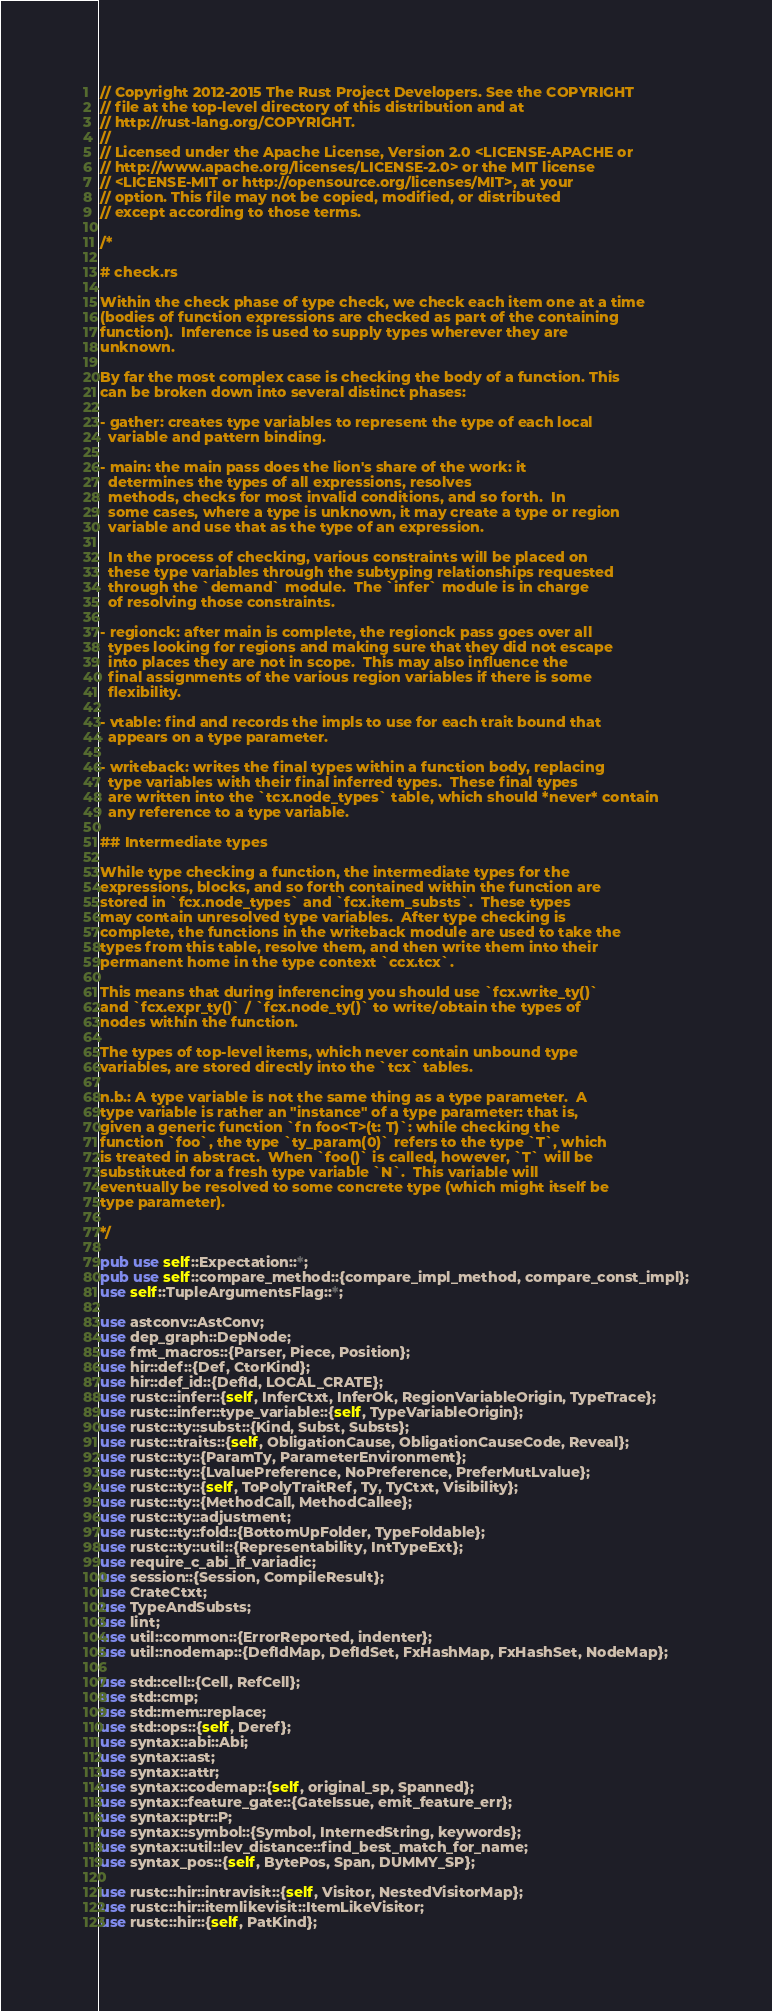Convert code to text. <code><loc_0><loc_0><loc_500><loc_500><_Rust_>// Copyright 2012-2015 The Rust Project Developers. See the COPYRIGHT
// file at the top-level directory of this distribution and at
// http://rust-lang.org/COPYRIGHT.
//
// Licensed under the Apache License, Version 2.0 <LICENSE-APACHE or
// http://www.apache.org/licenses/LICENSE-2.0> or the MIT license
// <LICENSE-MIT or http://opensource.org/licenses/MIT>, at your
// option. This file may not be copied, modified, or distributed
// except according to those terms.

/*

# check.rs

Within the check phase of type check, we check each item one at a time
(bodies of function expressions are checked as part of the containing
function).  Inference is used to supply types wherever they are
unknown.

By far the most complex case is checking the body of a function. This
can be broken down into several distinct phases:

- gather: creates type variables to represent the type of each local
  variable and pattern binding.

- main: the main pass does the lion's share of the work: it
  determines the types of all expressions, resolves
  methods, checks for most invalid conditions, and so forth.  In
  some cases, where a type is unknown, it may create a type or region
  variable and use that as the type of an expression.

  In the process of checking, various constraints will be placed on
  these type variables through the subtyping relationships requested
  through the `demand` module.  The `infer` module is in charge
  of resolving those constraints.

- regionck: after main is complete, the regionck pass goes over all
  types looking for regions and making sure that they did not escape
  into places they are not in scope.  This may also influence the
  final assignments of the various region variables if there is some
  flexibility.

- vtable: find and records the impls to use for each trait bound that
  appears on a type parameter.

- writeback: writes the final types within a function body, replacing
  type variables with their final inferred types.  These final types
  are written into the `tcx.node_types` table, which should *never* contain
  any reference to a type variable.

## Intermediate types

While type checking a function, the intermediate types for the
expressions, blocks, and so forth contained within the function are
stored in `fcx.node_types` and `fcx.item_substs`.  These types
may contain unresolved type variables.  After type checking is
complete, the functions in the writeback module are used to take the
types from this table, resolve them, and then write them into their
permanent home in the type context `ccx.tcx`.

This means that during inferencing you should use `fcx.write_ty()`
and `fcx.expr_ty()` / `fcx.node_ty()` to write/obtain the types of
nodes within the function.

The types of top-level items, which never contain unbound type
variables, are stored directly into the `tcx` tables.

n.b.: A type variable is not the same thing as a type parameter.  A
type variable is rather an "instance" of a type parameter: that is,
given a generic function `fn foo<T>(t: T)`: while checking the
function `foo`, the type `ty_param(0)` refers to the type `T`, which
is treated in abstract.  When `foo()` is called, however, `T` will be
substituted for a fresh type variable `N`.  This variable will
eventually be resolved to some concrete type (which might itself be
type parameter).

*/

pub use self::Expectation::*;
pub use self::compare_method::{compare_impl_method, compare_const_impl};
use self::TupleArgumentsFlag::*;

use astconv::AstConv;
use dep_graph::DepNode;
use fmt_macros::{Parser, Piece, Position};
use hir::def::{Def, CtorKind};
use hir::def_id::{DefId, LOCAL_CRATE};
use rustc::infer::{self, InferCtxt, InferOk, RegionVariableOrigin, TypeTrace};
use rustc::infer::type_variable::{self, TypeVariableOrigin};
use rustc::ty::subst::{Kind, Subst, Substs};
use rustc::traits::{self, ObligationCause, ObligationCauseCode, Reveal};
use rustc::ty::{ParamTy, ParameterEnvironment};
use rustc::ty::{LvaluePreference, NoPreference, PreferMutLvalue};
use rustc::ty::{self, ToPolyTraitRef, Ty, TyCtxt, Visibility};
use rustc::ty::{MethodCall, MethodCallee};
use rustc::ty::adjustment;
use rustc::ty::fold::{BottomUpFolder, TypeFoldable};
use rustc::ty::util::{Representability, IntTypeExt};
use require_c_abi_if_variadic;
use session::{Session, CompileResult};
use CrateCtxt;
use TypeAndSubsts;
use lint;
use util::common::{ErrorReported, indenter};
use util::nodemap::{DefIdMap, DefIdSet, FxHashMap, FxHashSet, NodeMap};

use std::cell::{Cell, RefCell};
use std::cmp;
use std::mem::replace;
use std::ops::{self, Deref};
use syntax::abi::Abi;
use syntax::ast;
use syntax::attr;
use syntax::codemap::{self, original_sp, Spanned};
use syntax::feature_gate::{GateIssue, emit_feature_err};
use syntax::ptr::P;
use syntax::symbol::{Symbol, InternedString, keywords};
use syntax::util::lev_distance::find_best_match_for_name;
use syntax_pos::{self, BytePos, Span, DUMMY_SP};

use rustc::hir::intravisit::{self, Visitor, NestedVisitorMap};
use rustc::hir::itemlikevisit::ItemLikeVisitor;
use rustc::hir::{self, PatKind};</code> 